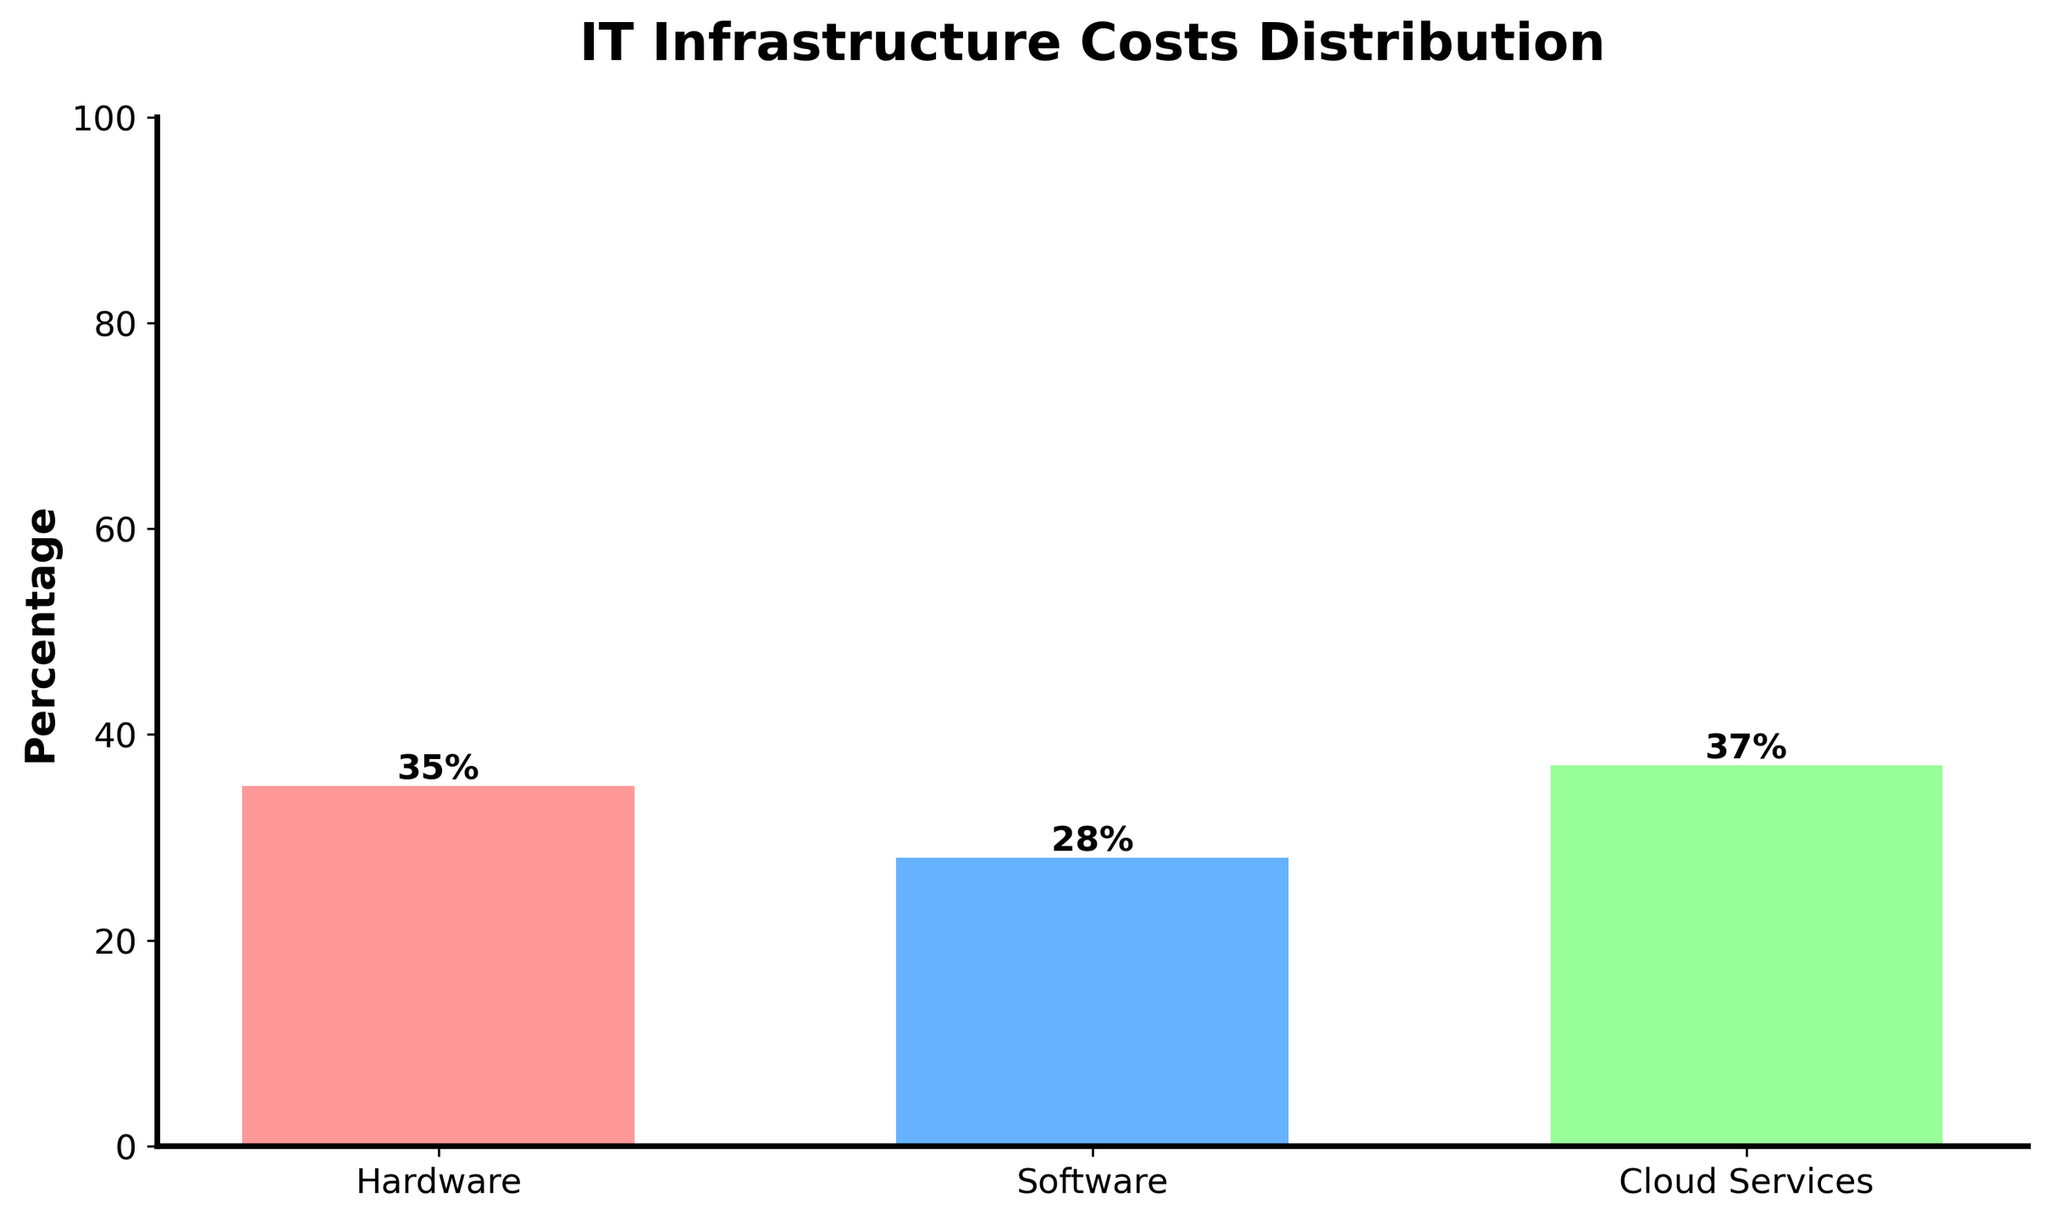What is the percentage of cloud services costs? Look at the corresponding bar labeled "Cloud Services"; the height of the bar indicates its percentage which is labeled directly on the bar.
Answer: 37% Which category has the highest cost percentage? Compare the heights of all the bars; the one with the tallest bar indicates the highest percentage.
Answer: Cloud Services By how much does the hardware cost percentage exceed the software cost percentage? Find the difference by subtracting the software percentage (28%) from the hardware percentage (35%). The calculation is 35% - 28% = 7%.
Answer: 7% What is the combined percentage cost of hardware and software? Add the percentages for hardware (35%) and software (28%). The calculation is 35% + 28% = 63%.
Answer: 63% Which categories have a cost percentage less than 35%? Identify the bars that fall below the 35% mark. Software (28%) and Hardware (35%) meet this condition.
Answer: Software How does the cost percentage for software compare to the cost percentage for cloud services? Compare the heights of the "Software" and "Cloud Services" bars; the software percentage (28%) is less than the cloud services percentage (37%).
Answer: Less than If the total IT infrastructure costs were $1,000,000, how much would be spent on cloud services? Use the percentage for cloud services (37%) to find the cost: 37% of $1,000,000. The calculation is 0.37 * $1,000,000 = $370,000.
Answer: $370,000 Which bar on the chart is represented in green? Identify the color coding in the bar chart; the green bar corresponds to "Cloud Services".
Answer: Cloud Services 